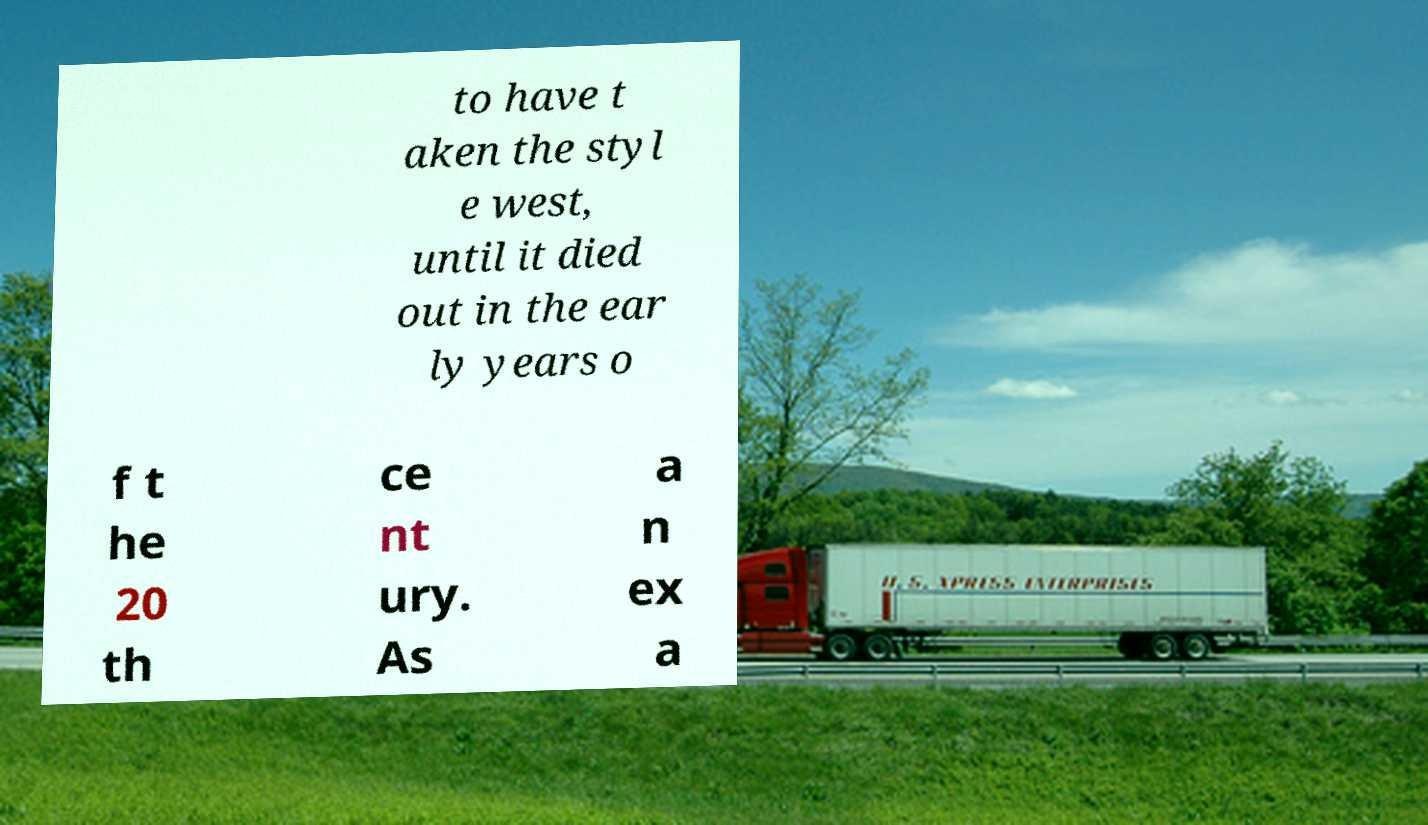Could you assist in decoding the text presented in this image and type it out clearly? to have t aken the styl e west, until it died out in the ear ly years o f t he 20 th ce nt ury. As a n ex a 